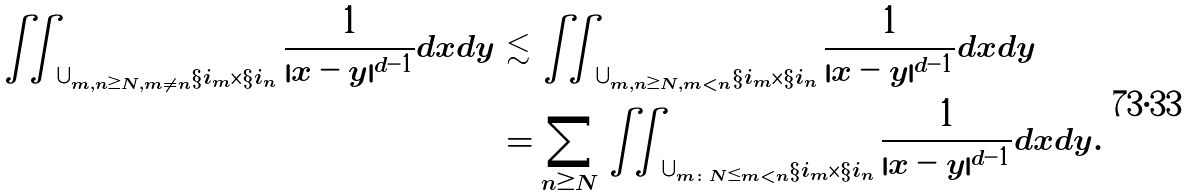<formula> <loc_0><loc_0><loc_500><loc_500>\iint _ { \cup _ { m , n \geq N , m \neq n } \S i _ { m } \times \S i _ { n } } \frac { 1 } { | x - y | ^ { d - 1 } } d x d y & \lesssim \iint _ { \cup _ { m , n \geq N , m < n } \S i _ { m } \times \S i _ { n } } \frac { 1 } { | x - y | ^ { d - 1 } } d x d y \\ & = \sum _ { n \geq N } \iint _ { \cup _ { m \colon N \leq m < n } \S i _ { m } \times \S i _ { n } } \frac { 1 } { | x - y | ^ { d - 1 } } d x d y .</formula> 